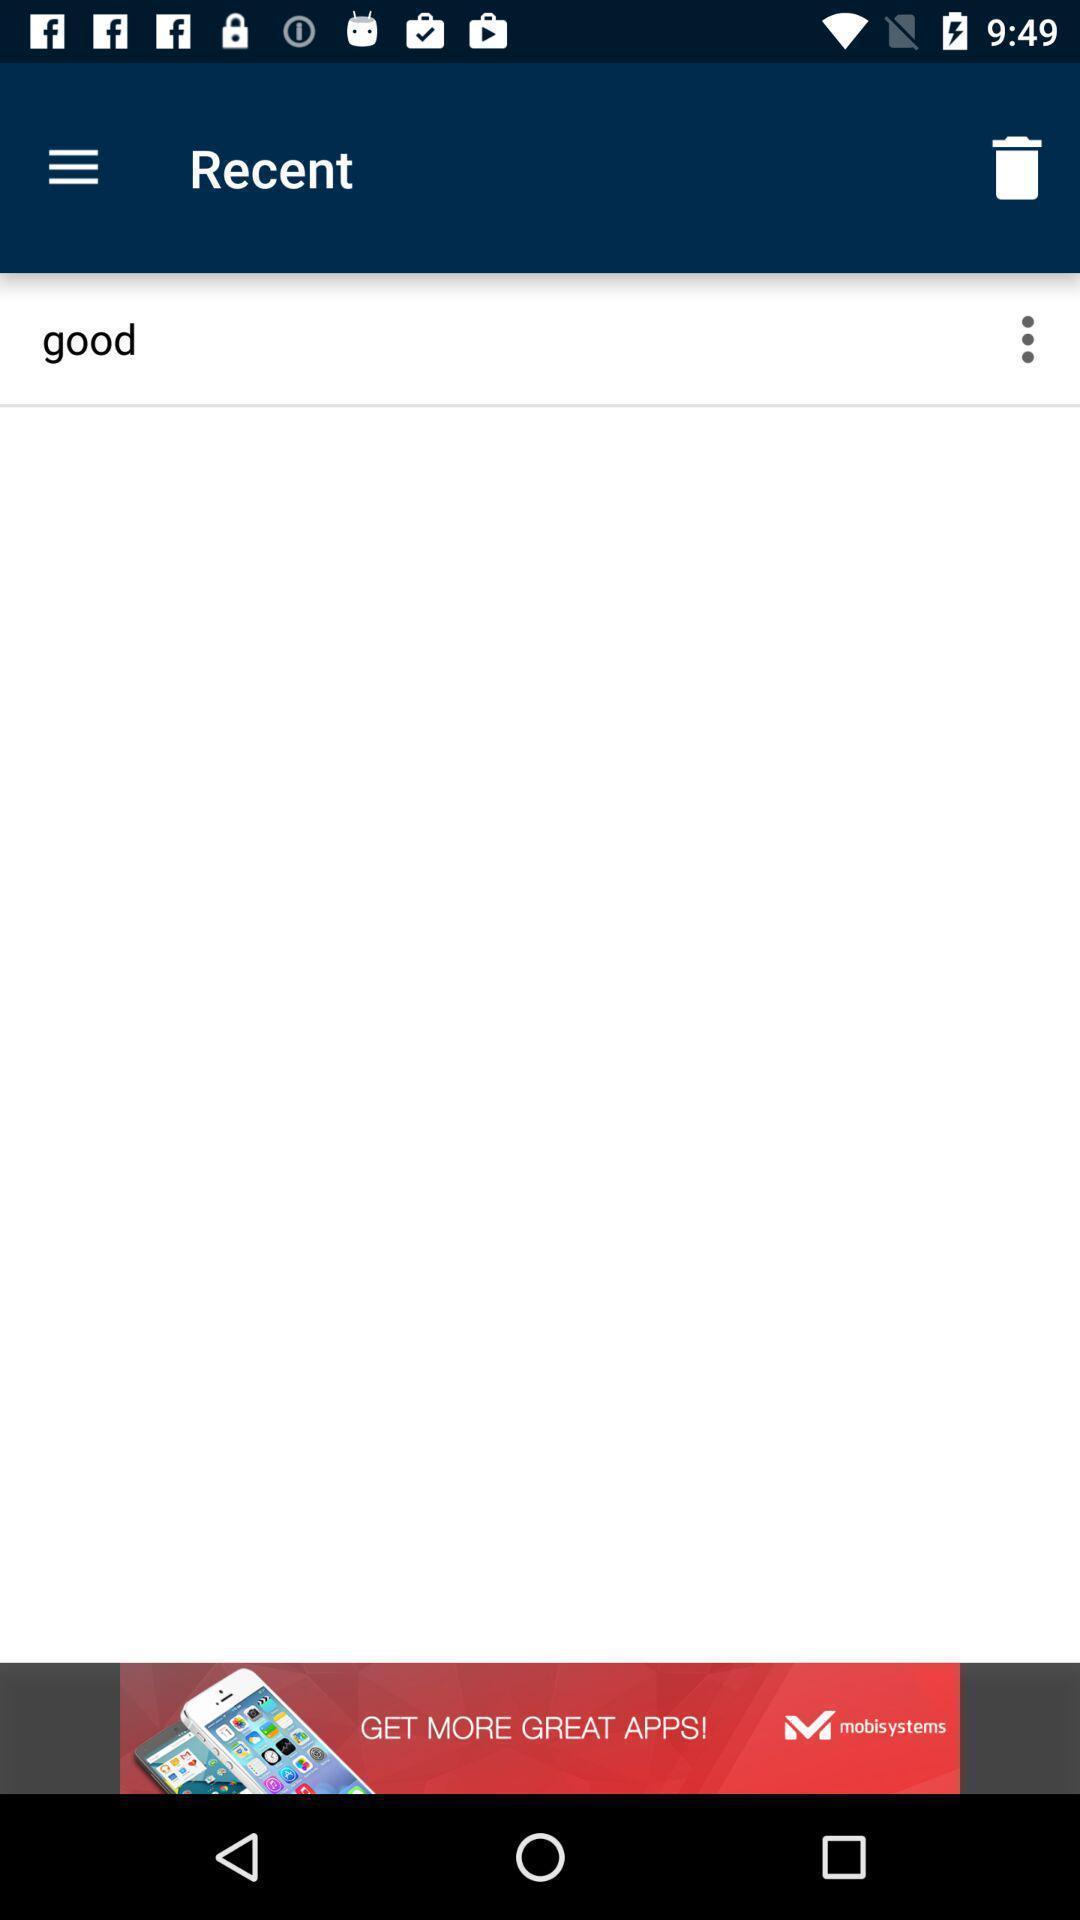What details can you identify in this image? Word in recent page of a dictionary app. 